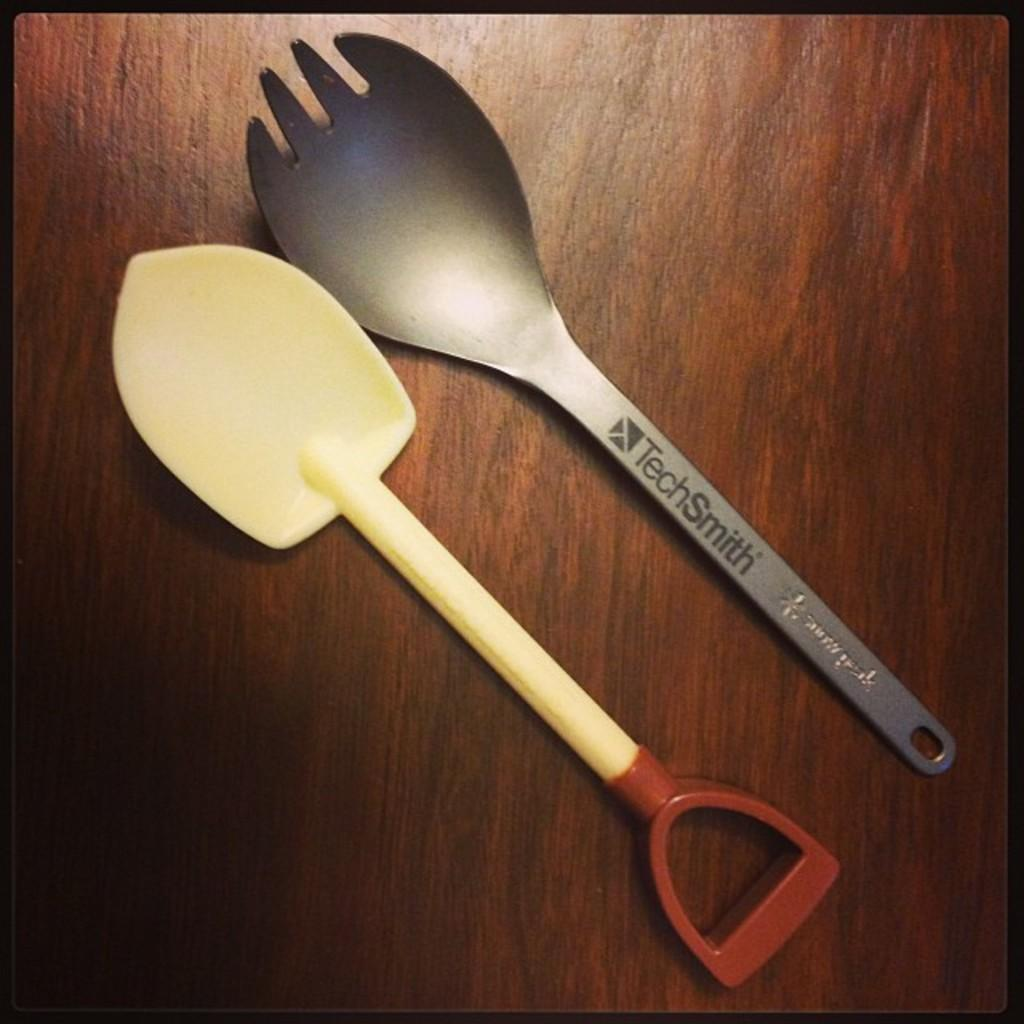What type of tool is in the image? There is a trowel in the image. What other utensil can be seen in the image? There is a fork in the image. Where are the trowel and fork placed in the image? The trowel and fork are placed on a wooden table. What type of connection is established between the trowel and the lawyer in the image? There is no lawyer present in the image, and therefore no connection can be established between the trowel and a lawyer. What part of the trowel is visible in the image? The image does not focus on a specific part of the trowel; it shows the entire tool. 